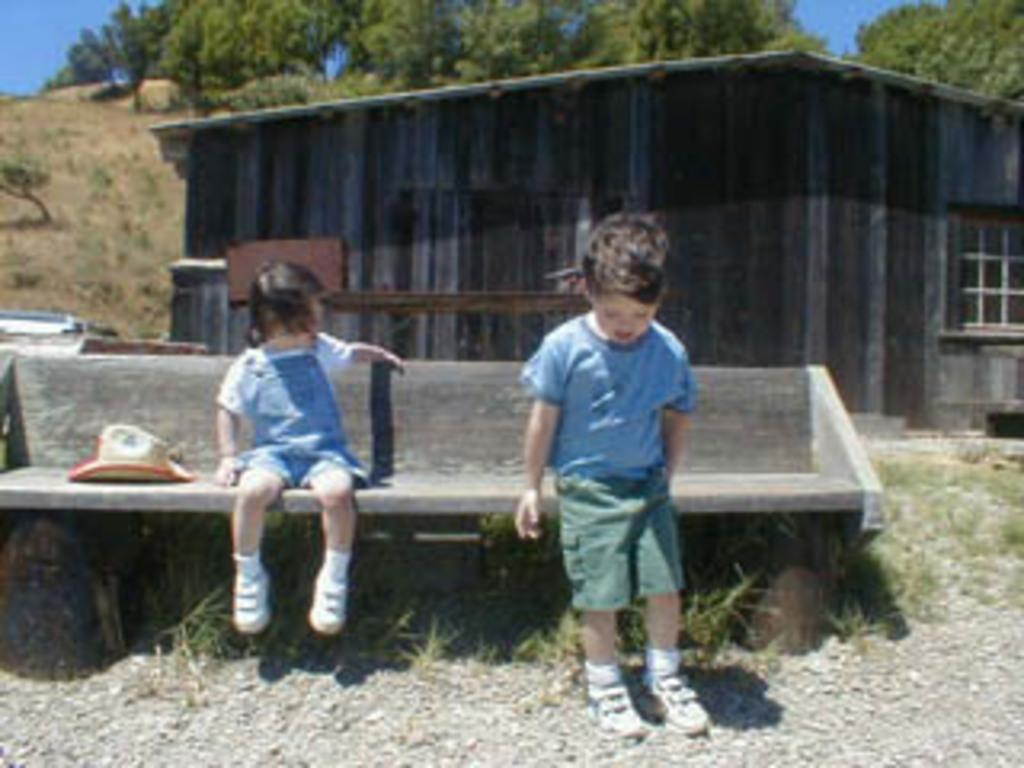How many children are in the image? There are two children in the image. What are the positions of the children in the image? One child is sitting on a bench, and the other child is standing on a path. What can be seen in the background of the image? There is grass, a house, and many trees visible in the background. What type of star can be seen shining in the image? There is no star visible in the image; it is set in a grassy area with trees and a house in the background. 